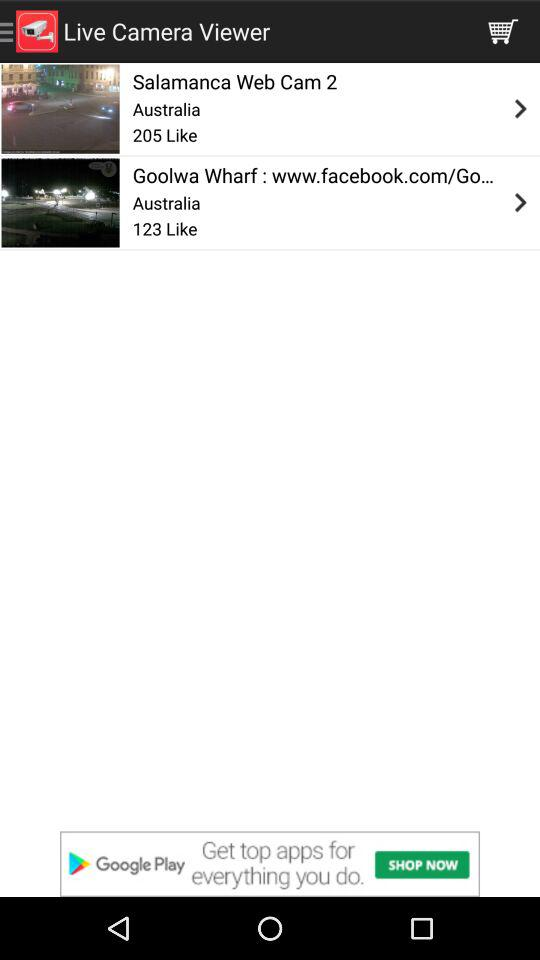How many people have liked the Salamanca Web Cam 2 camera? There are 205 likes. 